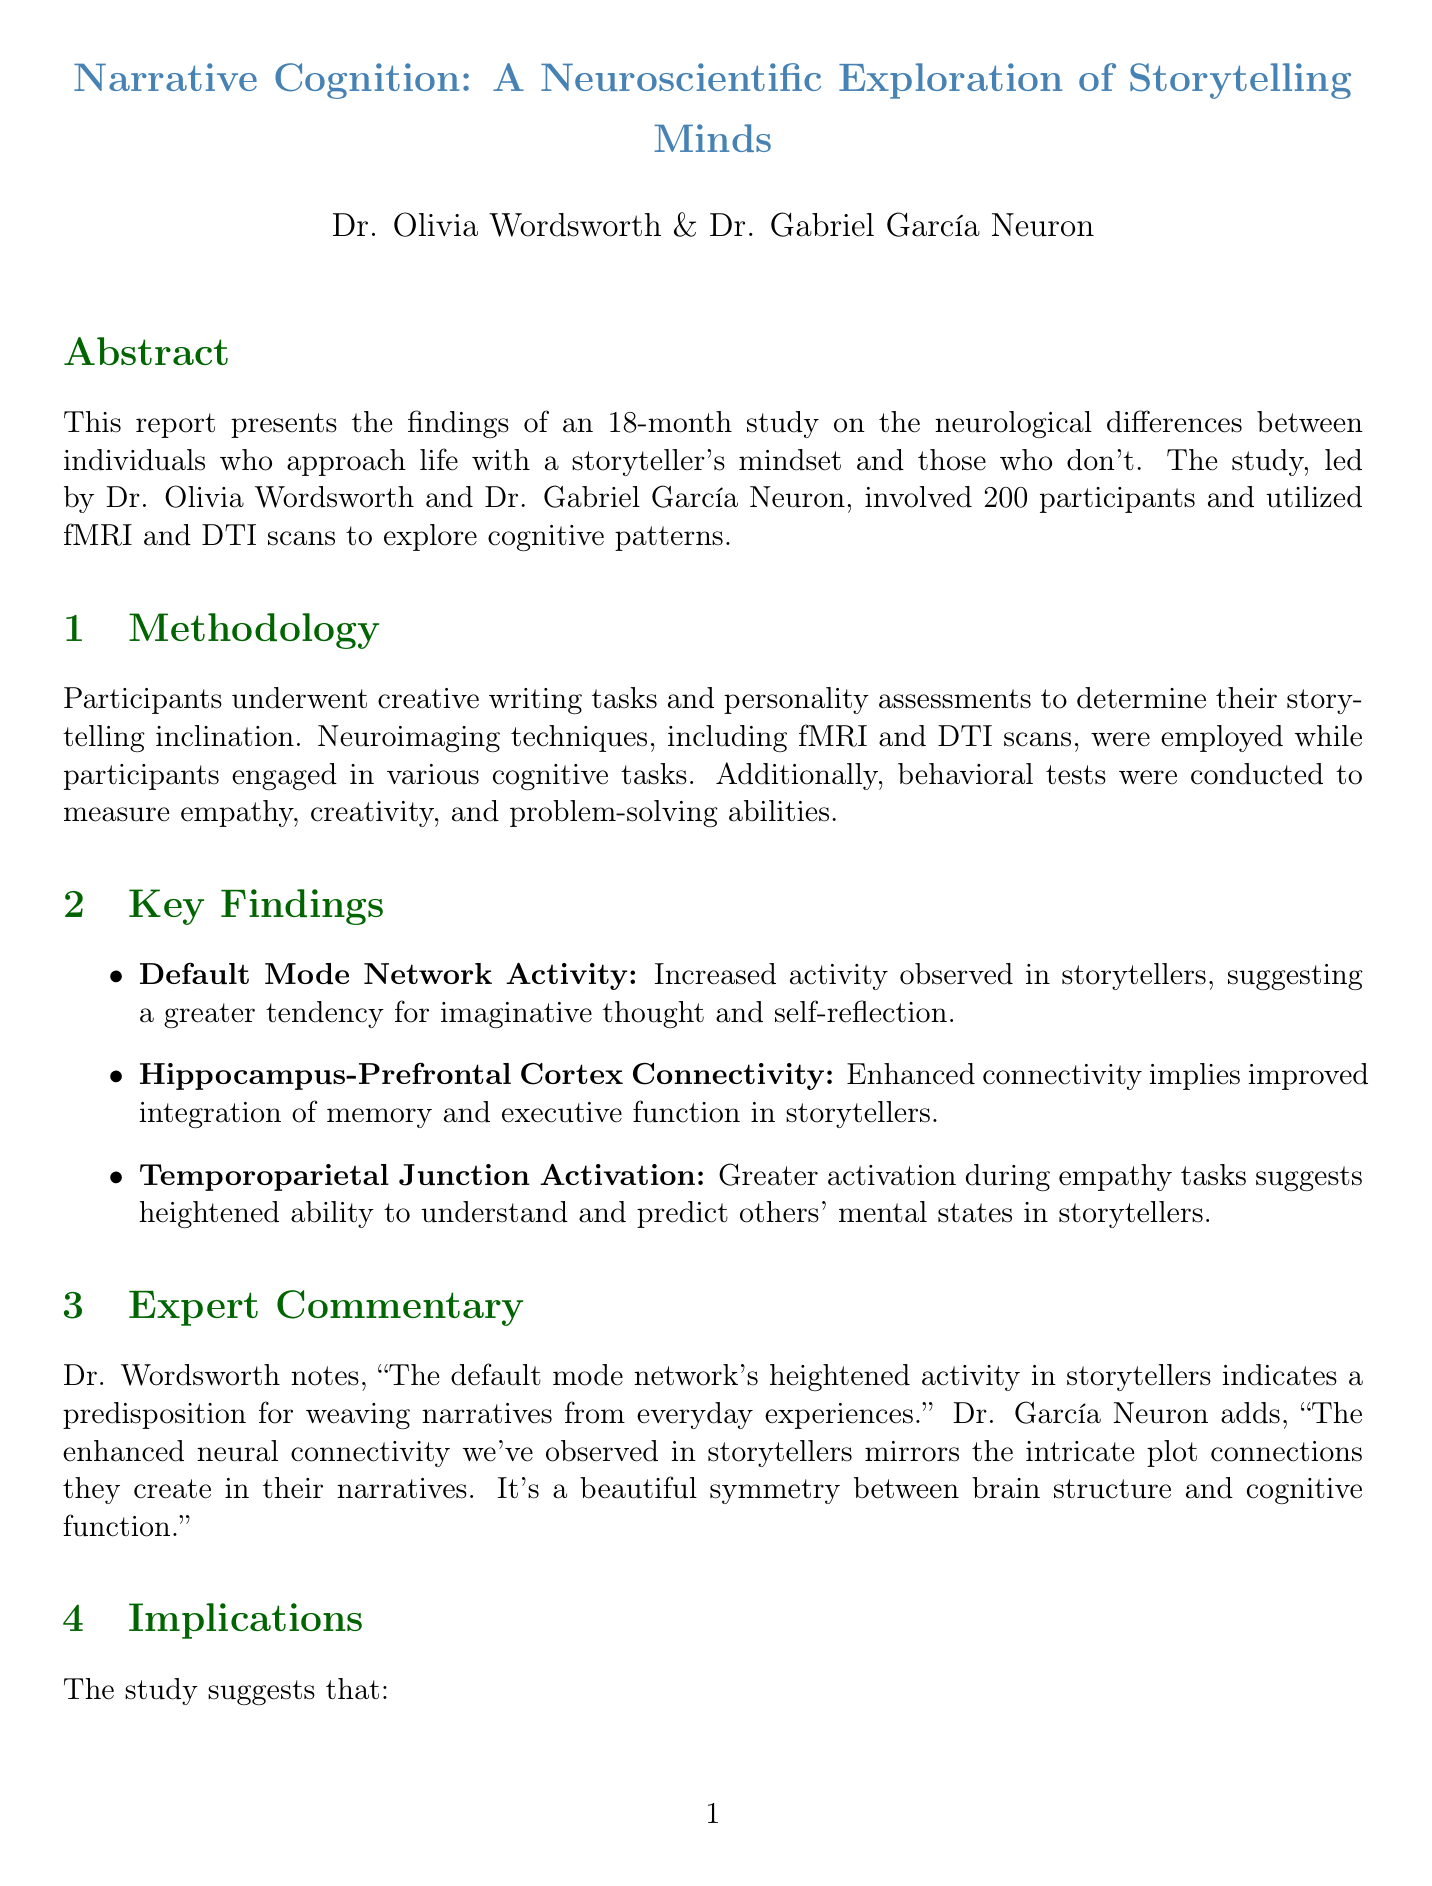What is the title of the study? The title is provided at the beginning of the document, which articulates the focus of the research.
Answer: Narrative Cognition: A Neuroscientific Exploration of Storytelling Minds Who are the lead researchers? The section lists the names and affiliations of the principal investigators of the study.
Answer: Dr. Olivia Wordsworth and Dr. Gabriel García Neuron How long did the study last? The duration of the study is explicitly mentioned in the document.
Answer: 18 months What is the total number of participants in the study? The document provides a summary of the participant demographics.
Answer: 200 What brain areas showed increased activity in storytellers? This observation is connected to the findings regarding storytelling cognition mentioned in the study.
Answer: Default mode network What is one implication of the study's findings? The implications section outlines potential applications of the research results.
Answer: Storytellers may have a neurological advantage in fields requiring empathy and creativity What type of imaging was used in the study? The methodology section specifies the types of scans used for participants.
Answer: fMRI and DTI scans What future research direction involves storytelling development? The future research directions outline potential areas for further investigation based on current findings.
Answer: Longitudinal studies to determine if storytelling tendencies can be developed over time What is the main focus of the research? The abstract outlines the essence and intent of the study.
Answer: Neurological differences between individuals who approach life with a storyteller's mindset and those who don't 